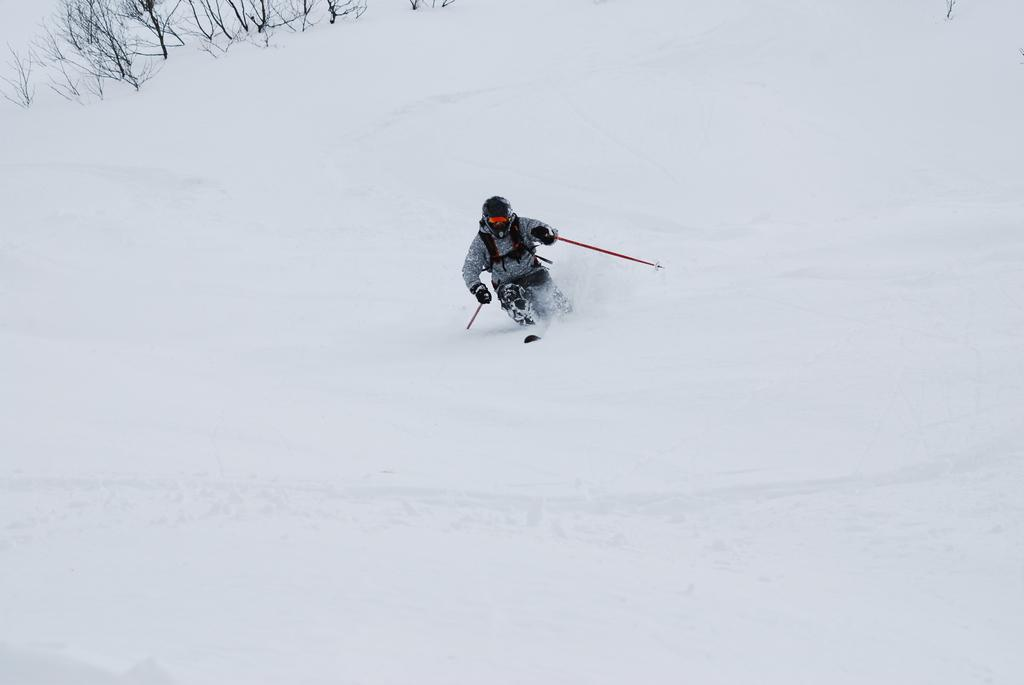What activity is the person in the image engaged in? The person is skiing in the image. What surface is the person skiing on? The person is skiing on snow. What can be seen in the background of the image? There are plants in the background of the image. What type of jam is the person eating while skiing in the image? There is no jam or food present in the image; the person is skiing on snow. 